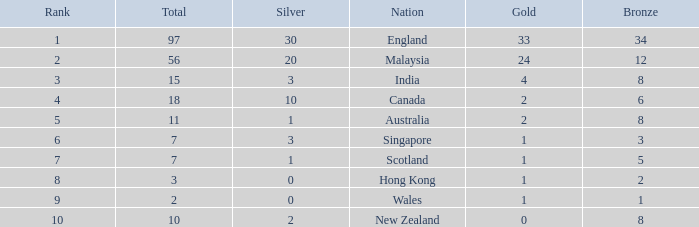What is the total number of bronze a team with more than 0 silver, a total of 7 medals, and less than 1 gold medal has? 0.0. 